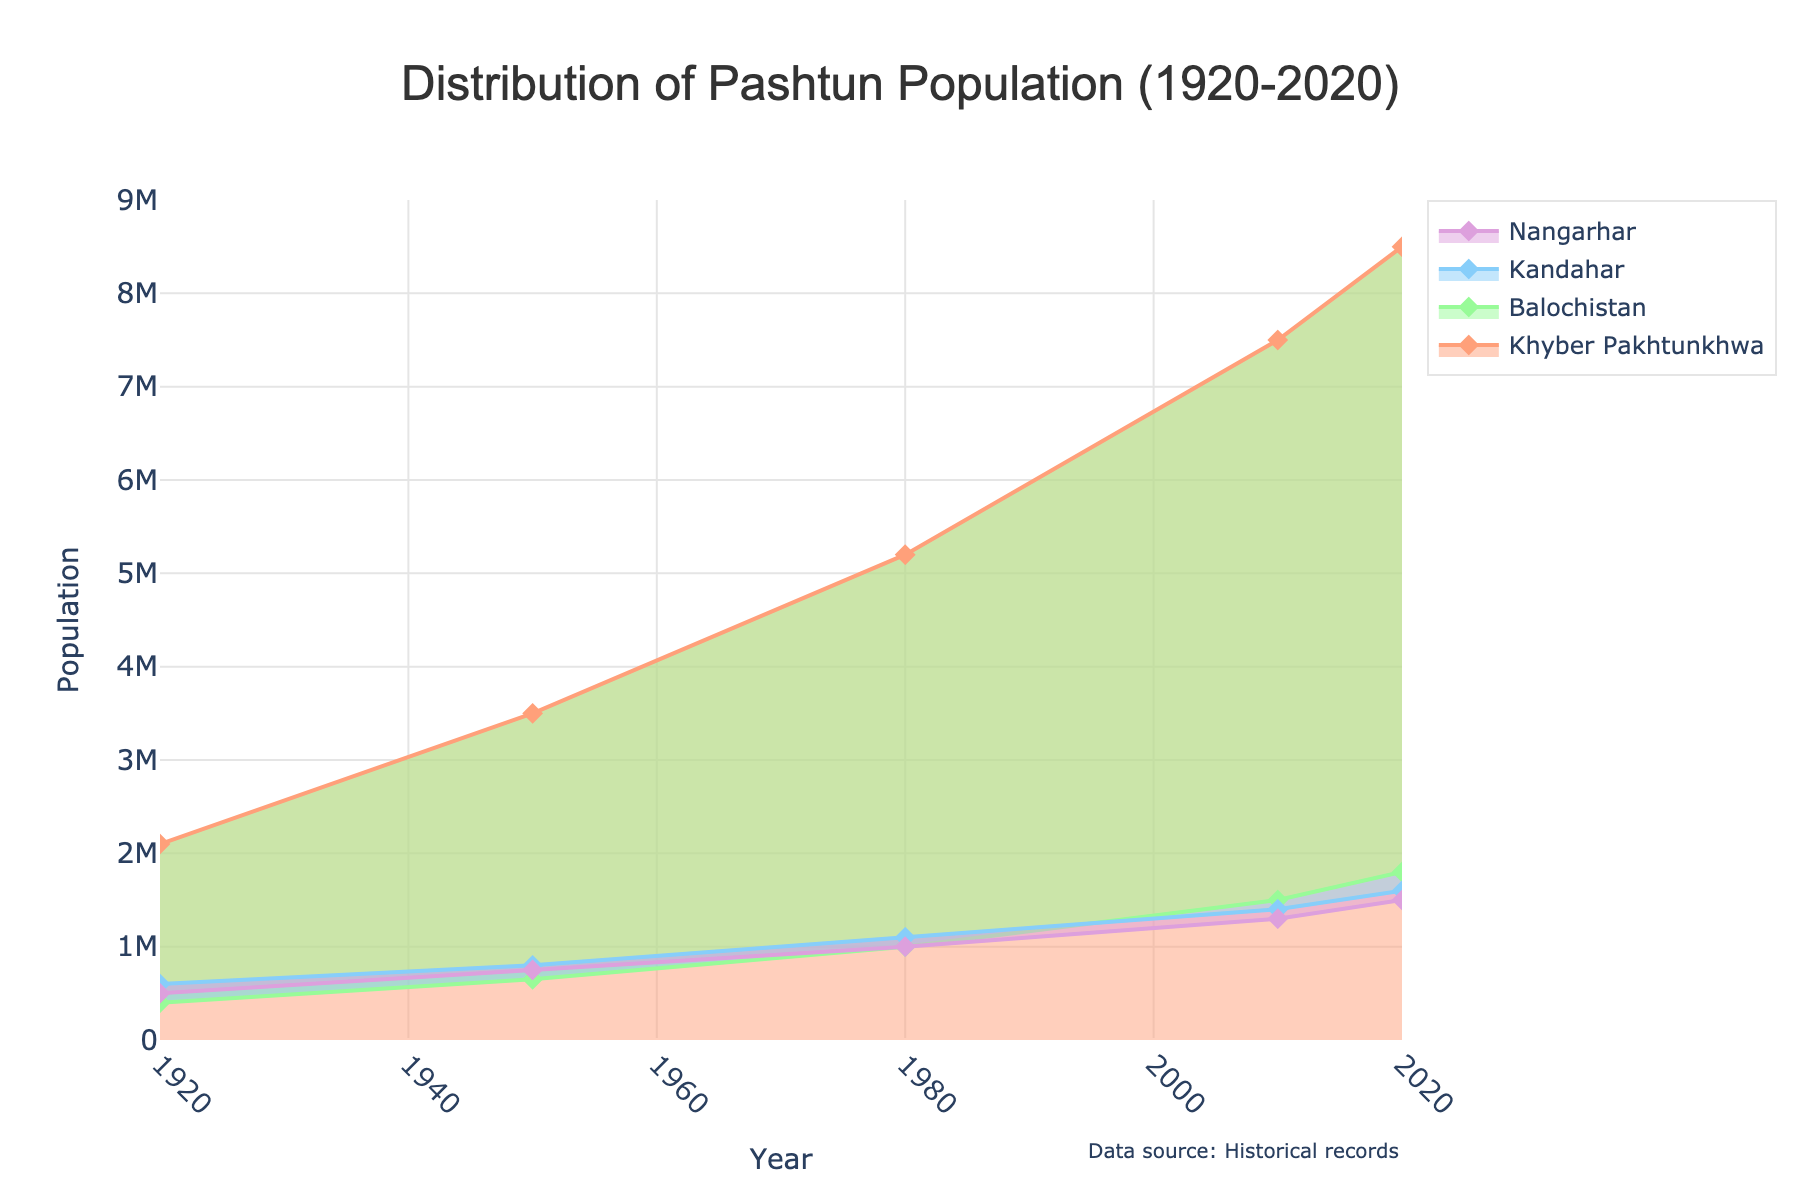What is the title of the chart? The title is located at the top of the chart. It should be clearly visible in a larger font size.
Answer: Distribution of Pashtun Population (1920-2020) Which region had the highest Pashtun population in 2020? By looking at the population values for each region in 2020, you can see which region's curve is the highest.
Answer: Khyber Pakhtunkhwa How many years are displayed on the x-axis? Count the distinct years shown along the x-axis. Each tick mark represents a specific year.
Answer: 5 What does the y-axis represent? The y-axis typically has a label that indicates what is being measured. Here, it should be population.
Answer: Population Between which years did Nangarhar see the biggest increase in population? Compare the population values at different years for Nangarhar and identify the period with the largest difference.
Answer: 1920 to 1950 Which regions had a population of around 1,000,000 in 1980? Look at the y-axis and find the regions that have a data point around the 1,000,000 mark in the year 1980.
Answer: Balochistan, Kandahar, Nangarhar Compare the population growth of Khyber Pakhtunkhwa from 1920 to 2020 with that of Balochistan for the same period. Calculate the difference in population for Khyber Pakhtunkhwa and Balochistan between 1920 and 2020, and then compare these differences. Khyber Pakhtunkhwa: 8500000 - 2100000 = 6400000, Balochistan: 1800000 - 400000 = 1400000
Answer: Khyber Pakhtunkhwa had a larger growth What is the range of population values displayed on the y-axis? The values on the y-axis range from the minimum to the maximum displayed population.
Answer: 0 to 9000000 Which region showed the smallest increase in population between 2010 and 2020? Find the population values for each region in 2010 and 2020 and identify the smallest difference.
Answer: Nangarhar (200,000 increase) What is the overall trend of the Pashtun population in Khyber Pakhtunkhwa over the century? Observe the trajectory of the data points for Khyber Pakhtunkhwa from 1920 to 2020.
Answer: Increasing 